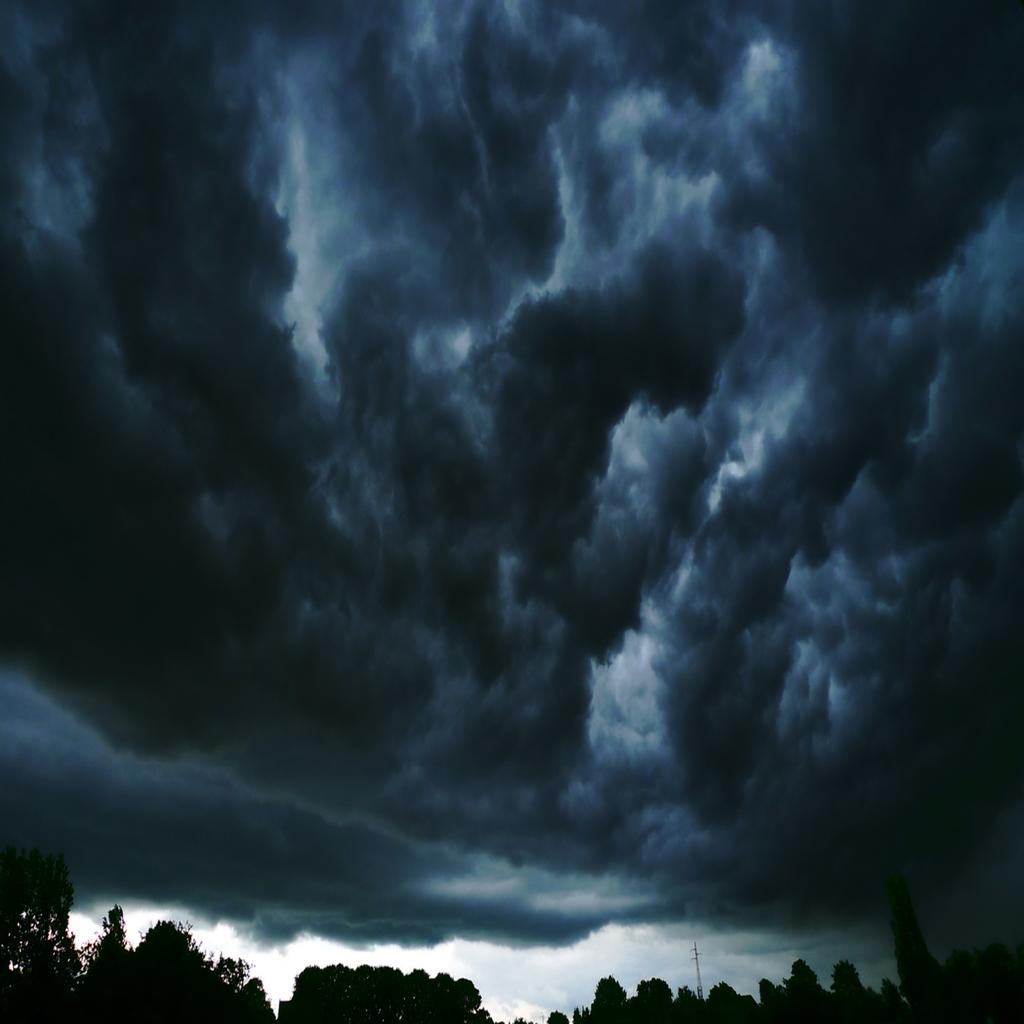What type of vegetation can be seen in the image? There are trees in the image. What is the condition of the sky in the image? The sky is cloudy in the image. What type of copper material is present in the image? There is no copper material present in the image; it features trees and a cloudy sky. What level of difficulty can be observed in the image? The image does not depict any activity or task that could be assigned a level of difficulty. 